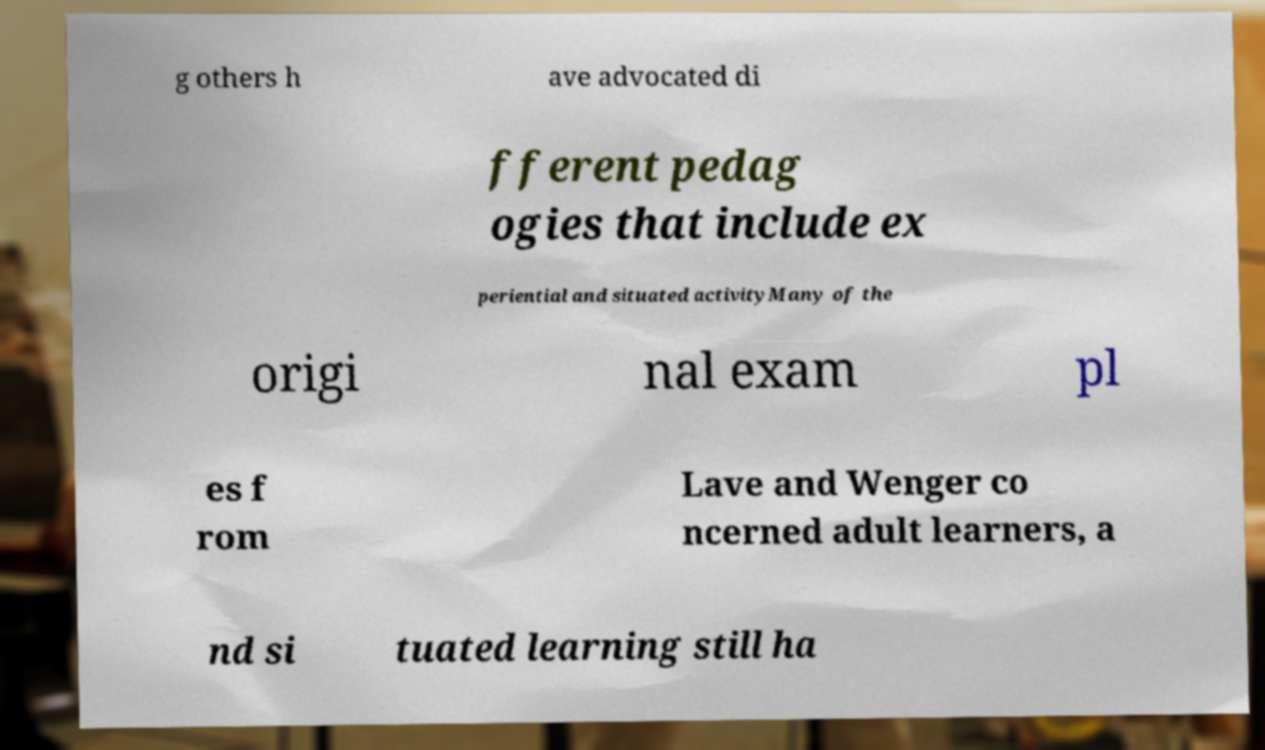Could you extract and type out the text from this image? g others h ave advocated di fferent pedag ogies that include ex periential and situated activityMany of the origi nal exam pl es f rom Lave and Wenger co ncerned adult learners, a nd si tuated learning still ha 